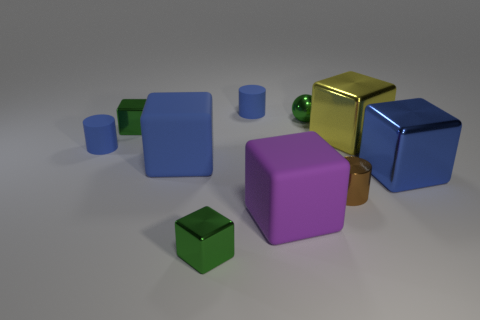What is the material of the yellow cube to the right of the tiny green sphere?
Keep it short and to the point. Metal. There is a tiny blue matte object that is on the right side of the green block left of the green object in front of the metal cylinder; what is its shape?
Make the answer very short. Cylinder. There is a tiny sphere behind the brown metallic cylinder; does it have the same color as the matte object in front of the blue metallic object?
Keep it short and to the point. No. Are there fewer green spheres to the right of the brown metallic thing than tiny blue cylinders that are to the left of the blue rubber block?
Provide a short and direct response. Yes. Are there any other things that have the same shape as the big yellow object?
Give a very brief answer. Yes. There is another big matte object that is the same shape as the purple matte thing; what color is it?
Your answer should be very brief. Blue. Does the small brown shiny thing have the same shape as the matte thing that is on the left side of the big blue matte thing?
Offer a very short reply. Yes. What number of objects are either metal cubes right of the large blue matte cube or blue cubes that are on the right side of the small shiny cylinder?
Your response must be concise. 3. What material is the green sphere?
Your answer should be compact. Metal. How many other things are there of the same size as the blue metal block?
Ensure brevity in your answer.  3. 